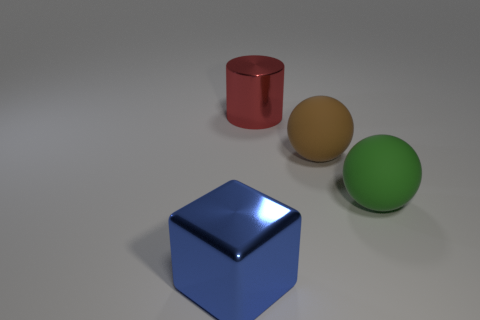There is a matte object behind the big matte object in front of the large brown rubber thing; what is its size?
Keep it short and to the point. Large. There is a object that is behind the big green matte object and right of the big metallic cylinder; what is it made of?
Offer a very short reply. Rubber. What material is the other object that is the same shape as the big brown thing?
Ensure brevity in your answer.  Rubber. Are the brown thing and the thing to the left of the big cylinder made of the same material?
Provide a short and direct response. No. What number of objects are large objects that are to the left of the large red thing or cyan objects?
Ensure brevity in your answer.  1. How many other things are the same size as the cylinder?
Your answer should be compact. 3. The large sphere that is right of the brown ball in front of the large metallic object behind the large blue metal block is made of what material?
Provide a succinct answer. Rubber. How many cubes are small brown matte objects or blue metal things?
Provide a short and direct response. 1. Is there any other thing that is the same shape as the red metallic object?
Give a very brief answer. No. Is the number of large brown rubber objects left of the large green matte sphere greater than the number of green things that are behind the big brown rubber sphere?
Keep it short and to the point. Yes. 